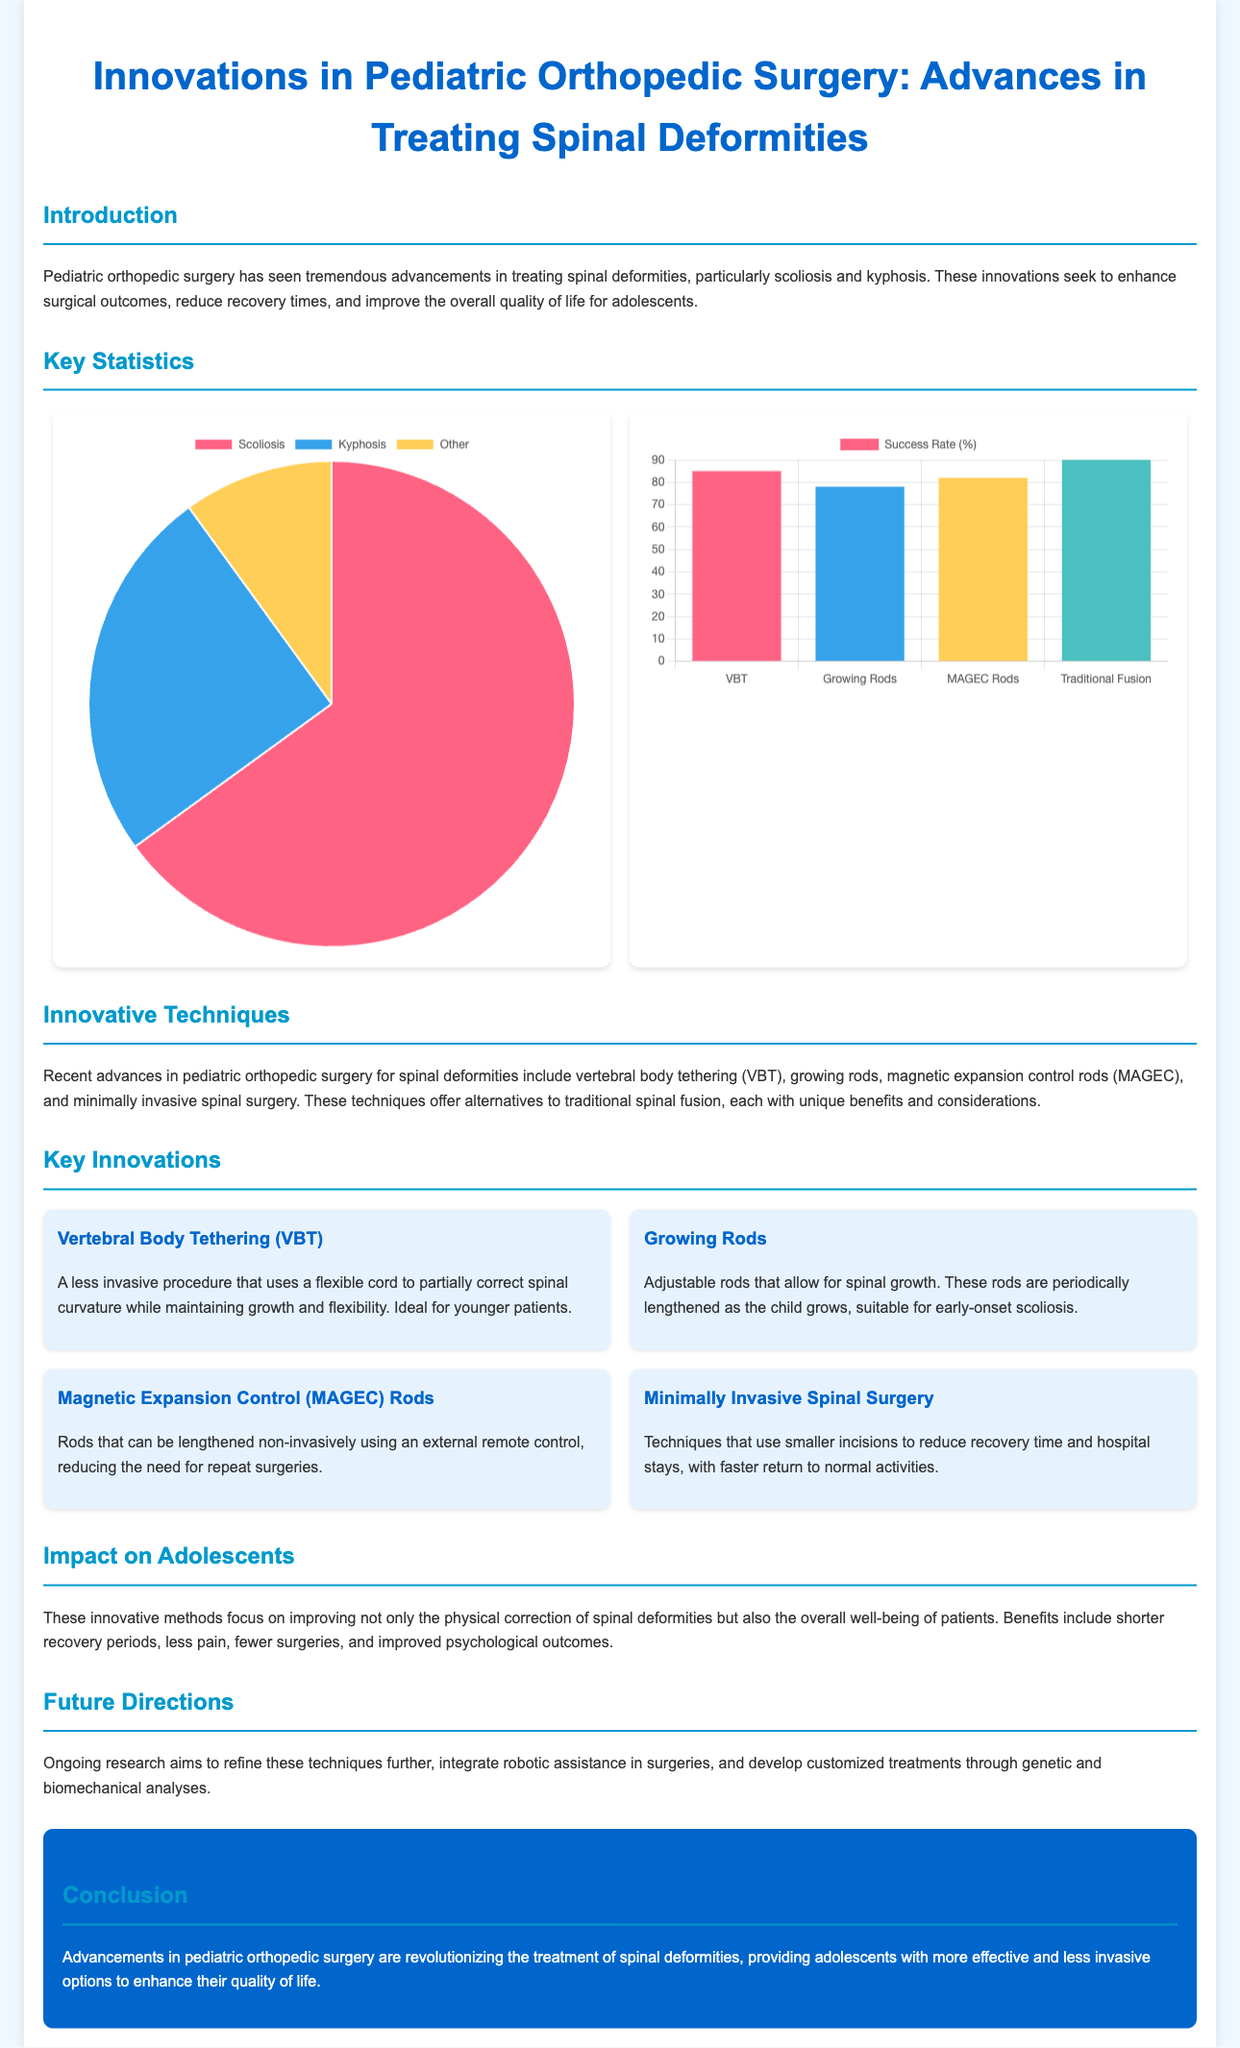What are the two primary spinal deformities discussed? The document highlights scoliosis and kyphosis as the primary spinal deformities being addressed.
Answer: Scoliosis, Kyphosis What is the success rate of Vertebral Body Tethering (VBT)? The bar chart shows that the success rate of VBT is 85%.
Answer: 85% What innovative technique uses adjustable rods? The document mentions Growing Rods as an innovative technique that allows for spinal growth with adjustable rods.
Answer: Growing Rods What percentage of adolescents have the "Other" category of spinal deformities? The pie chart indicates that 10% of adolescents fall into the "Other" category of spinal deformities.
Answer: 10% Which technique has the highest success rate according to the chart? The bar chart indicates that Traditional Fusion has the highest success rate at 90%.
Answer: Traditional Fusion What are the benefits mentioned for the innovative techniques? The document discusses benefits such as shorter recovery periods, less pain, fewer surgeries, and improved psychological outcomes.
Answer: Shorter recovery periods, less pain, fewer surgeries, improved psychological outcomes What is the color associated with Kyphosis in the pie chart? The pie chart uses the color blue to represent Kyphosis.
Answer: Blue What future direction in pediatric orthopedic surgery is highlighted in the document? The text mentions integrating robotic assistance in surgeries as a future direction.
Answer: Robotic assistance 